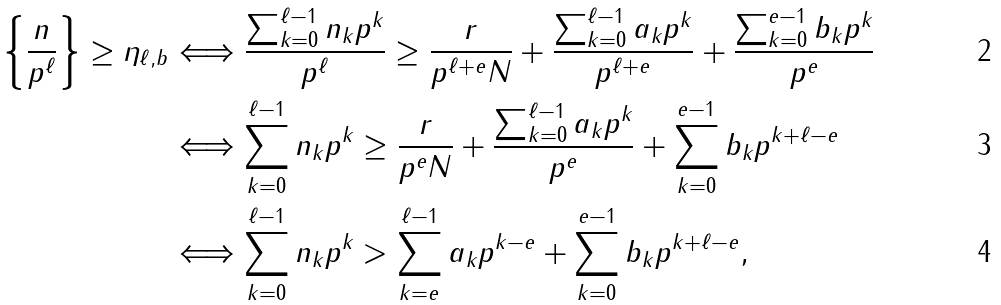Convert formula to latex. <formula><loc_0><loc_0><loc_500><loc_500>\left \{ \frac { n } { p ^ { \ell } } \right \} \geq \eta _ { \ell , b } & \Longleftrightarrow \frac { \sum _ { k = 0 } ^ { \ell - 1 } n _ { k } p ^ { k } } { p ^ { \ell } } \geq \frac { r } { p ^ { \ell + e } N } + \frac { \sum _ { k = 0 } ^ { \ell - 1 } a _ { k } p ^ { k } } { p ^ { \ell + e } } + \frac { \sum _ { k = 0 } ^ { e - 1 } b _ { k } p ^ { k } } { p ^ { e } } \\ & \Longleftrightarrow \sum _ { k = 0 } ^ { \ell - 1 } n _ { k } p ^ { k } \geq \frac { r } { p ^ { e } N } + \frac { \sum _ { k = 0 } ^ { \ell - 1 } a _ { k } p ^ { k } } { p ^ { e } } + \sum _ { k = 0 } ^ { e - 1 } b _ { k } p ^ { k + \ell - e } \\ & \Longleftrightarrow \sum _ { k = 0 } ^ { \ell - 1 } n _ { k } p ^ { k } > \sum _ { k = e } ^ { \ell - 1 } a _ { k } p ^ { k - e } + \sum _ { k = 0 } ^ { e - 1 } b _ { k } p ^ { k + \ell - e } ,</formula> 